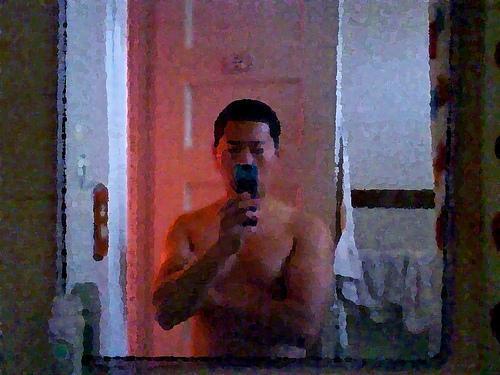How many people are in the picture?
Give a very brief answer. 1. How many pigs are taking a selfie in the mirror?
Give a very brief answer. 0. 